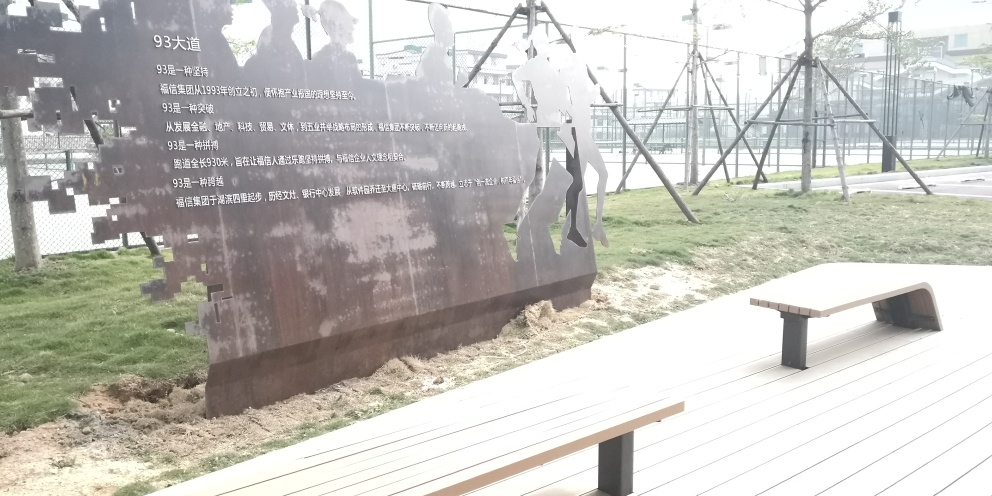What is the significance of the metal silhouette figures in this image? The metal silhouettes appear to be part of an outdoor art installation or memorial. These figures could represent people and moments from history or commemorate a specific event. The stark metal against the soft background suggests a narrative of resilience or remembrance. 